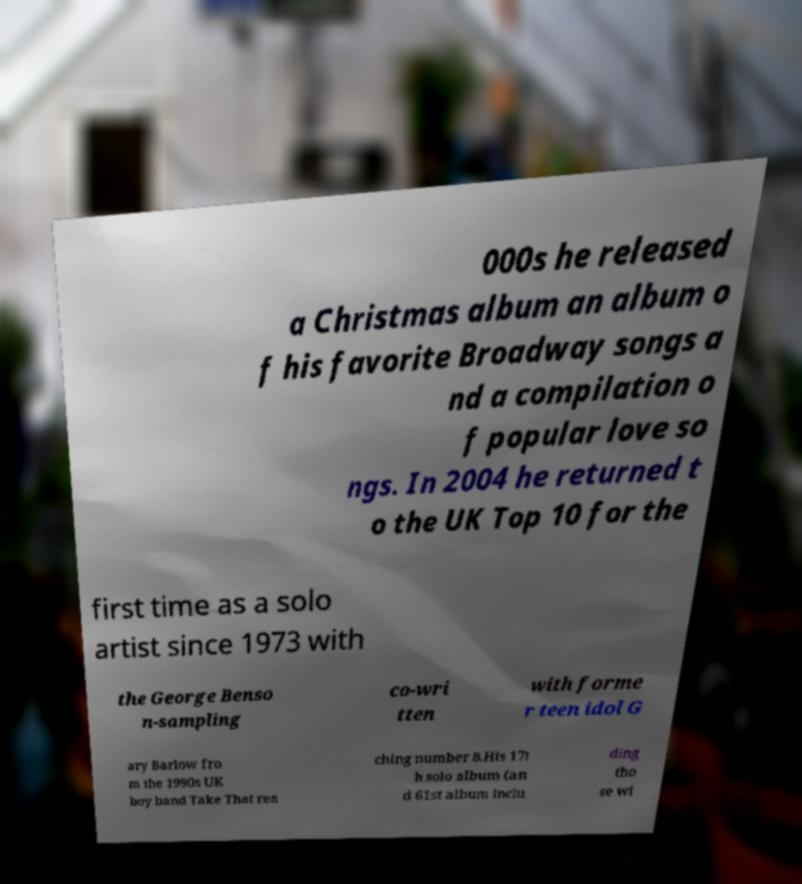There's text embedded in this image that I need extracted. Can you transcribe it verbatim? 000s he released a Christmas album an album o f his favorite Broadway songs a nd a compilation o f popular love so ngs. In 2004 he returned t o the UK Top 10 for the first time as a solo artist since 1973 with the George Benso n-sampling co-wri tten with forme r teen idol G ary Barlow fro m the 1990s UK boy band Take That rea ching number 8.His 17t h solo album (an d 61st album inclu ding tho se wi 